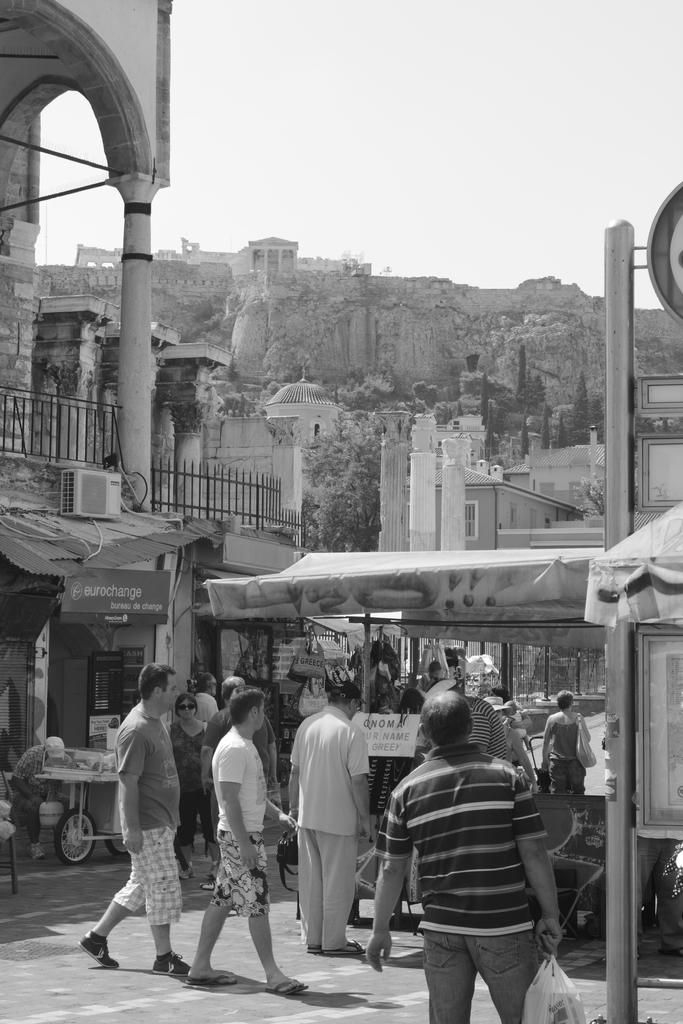What are the people in the image doing? The people in the image are walking. What are some people holding while walking? Some people are holding bags. What can be seen in the background of the image? In the background, there is a fort, a building, a railing, stores, boards, and vehicles. What is the color scheme of the image? The image is in black and white. What type of actor is performing on the stage in the image? There is no stage or actor present in the image; people are walking and there are various elements in the background. What is the size of the silver object in the image? There is no silver object present in the image. 